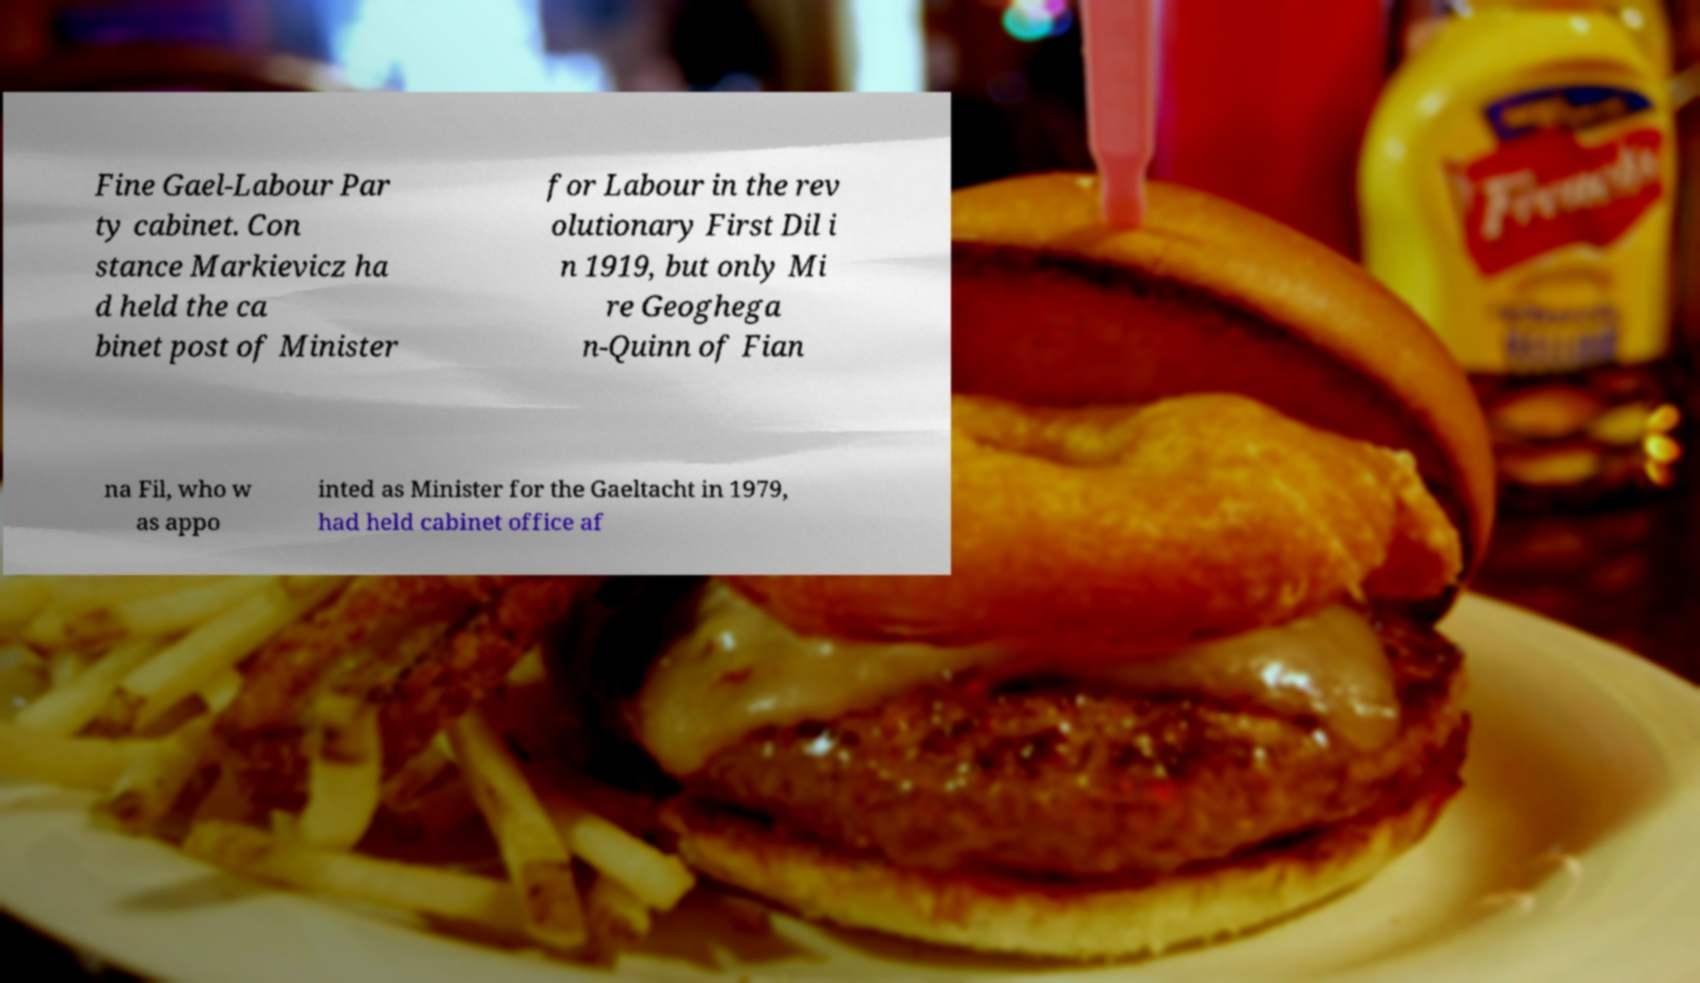Can you accurately transcribe the text from the provided image for me? Fine Gael-Labour Par ty cabinet. Con stance Markievicz ha d held the ca binet post of Minister for Labour in the rev olutionary First Dil i n 1919, but only Mi re Geoghega n-Quinn of Fian na Fil, who w as appo inted as Minister for the Gaeltacht in 1979, had held cabinet office af 